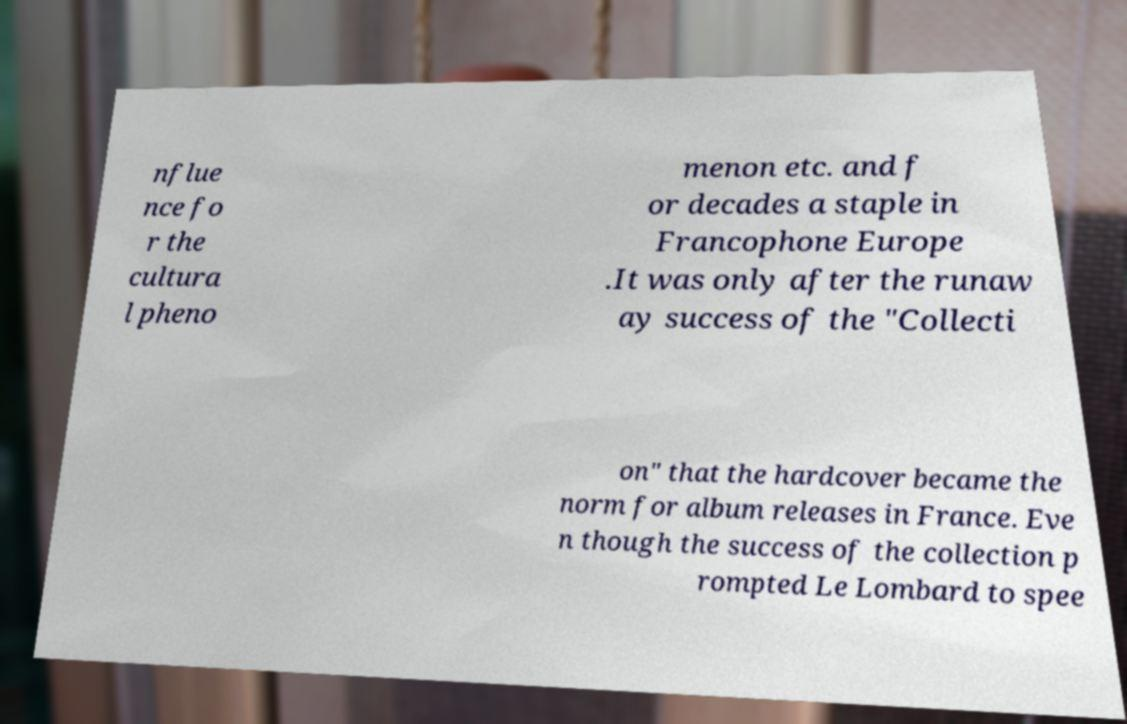Could you extract and type out the text from this image? nflue nce fo r the cultura l pheno menon etc. and f or decades a staple in Francophone Europe .It was only after the runaw ay success of the "Collecti on" that the hardcover became the norm for album releases in France. Eve n though the success of the collection p rompted Le Lombard to spee 